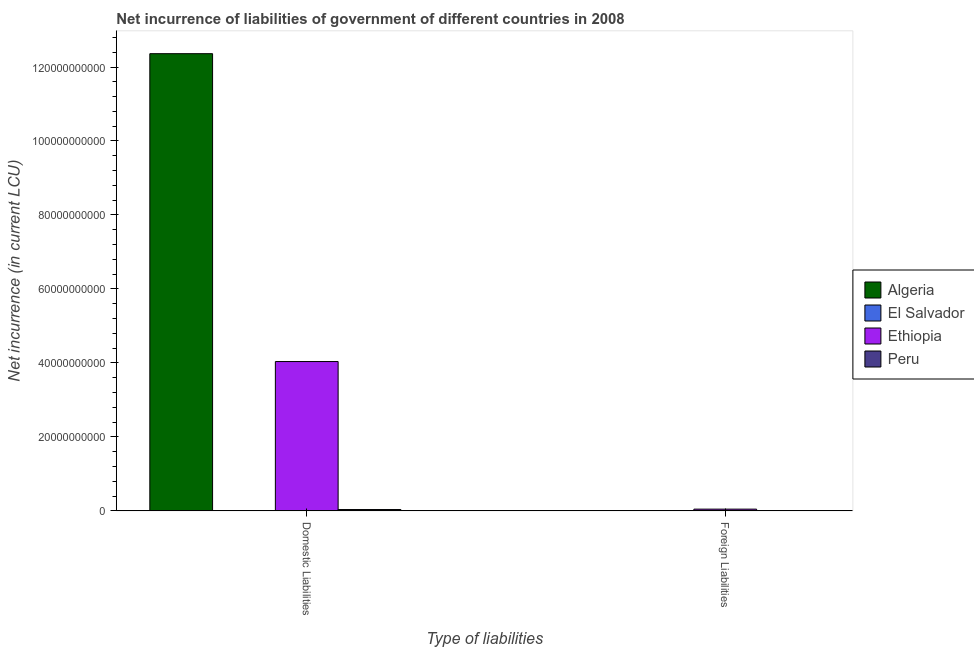How many different coloured bars are there?
Offer a terse response. 3. How many bars are there on the 1st tick from the left?
Ensure brevity in your answer.  3. How many bars are there on the 1st tick from the right?
Give a very brief answer. 1. What is the label of the 2nd group of bars from the left?
Give a very brief answer. Foreign Liabilities. What is the net incurrence of foreign liabilities in El Salvador?
Provide a short and direct response. 0. Across all countries, what is the maximum net incurrence of domestic liabilities?
Offer a terse response. 1.24e+11. In which country was the net incurrence of domestic liabilities maximum?
Your answer should be very brief. Algeria. What is the total net incurrence of foreign liabilities in the graph?
Provide a succinct answer. 4.74e+08. What is the difference between the net incurrence of domestic liabilities in Algeria and that in Ethiopia?
Your response must be concise. 8.32e+1. What is the difference between the net incurrence of domestic liabilities in El Salvador and the net incurrence of foreign liabilities in Ethiopia?
Ensure brevity in your answer.  -4.74e+08. What is the average net incurrence of domestic liabilities per country?
Your answer should be very brief. 4.11e+1. What is the difference between the net incurrence of domestic liabilities and net incurrence of foreign liabilities in Ethiopia?
Your response must be concise. 3.99e+1. What is the ratio of the net incurrence of domestic liabilities in Algeria to that in Ethiopia?
Give a very brief answer. 3.06. Is the net incurrence of domestic liabilities in Peru less than that in Algeria?
Give a very brief answer. Yes. In how many countries, is the net incurrence of foreign liabilities greater than the average net incurrence of foreign liabilities taken over all countries?
Provide a short and direct response. 1. How many bars are there?
Provide a succinct answer. 4. How many countries are there in the graph?
Your answer should be compact. 4. Are the values on the major ticks of Y-axis written in scientific E-notation?
Provide a succinct answer. No. Does the graph contain any zero values?
Ensure brevity in your answer.  Yes. Does the graph contain grids?
Your answer should be compact. No. How are the legend labels stacked?
Provide a succinct answer. Vertical. What is the title of the graph?
Your response must be concise. Net incurrence of liabilities of government of different countries in 2008. Does "Bermuda" appear as one of the legend labels in the graph?
Keep it short and to the point. No. What is the label or title of the X-axis?
Offer a terse response. Type of liabilities. What is the label or title of the Y-axis?
Give a very brief answer. Net incurrence (in current LCU). What is the Net incurrence (in current LCU) of Algeria in Domestic Liabilities?
Ensure brevity in your answer.  1.24e+11. What is the Net incurrence (in current LCU) in El Salvador in Domestic Liabilities?
Give a very brief answer. 0. What is the Net incurrence (in current LCU) of Ethiopia in Domestic Liabilities?
Ensure brevity in your answer.  4.04e+1. What is the Net incurrence (in current LCU) in Peru in Domestic Liabilities?
Offer a very short reply. 3.64e+08. What is the Net incurrence (in current LCU) of Algeria in Foreign Liabilities?
Offer a terse response. 0. What is the Net incurrence (in current LCU) of Ethiopia in Foreign Liabilities?
Offer a very short reply. 4.74e+08. What is the Net incurrence (in current LCU) in Peru in Foreign Liabilities?
Provide a short and direct response. 0. Across all Type of liabilities, what is the maximum Net incurrence (in current LCU) in Algeria?
Offer a very short reply. 1.24e+11. Across all Type of liabilities, what is the maximum Net incurrence (in current LCU) in Ethiopia?
Provide a succinct answer. 4.04e+1. Across all Type of liabilities, what is the maximum Net incurrence (in current LCU) in Peru?
Offer a very short reply. 3.64e+08. Across all Type of liabilities, what is the minimum Net incurrence (in current LCU) of Ethiopia?
Offer a terse response. 4.74e+08. What is the total Net incurrence (in current LCU) in Algeria in the graph?
Offer a very short reply. 1.24e+11. What is the total Net incurrence (in current LCU) in El Salvador in the graph?
Make the answer very short. 0. What is the total Net incurrence (in current LCU) in Ethiopia in the graph?
Give a very brief answer. 4.09e+1. What is the total Net incurrence (in current LCU) of Peru in the graph?
Make the answer very short. 3.64e+08. What is the difference between the Net incurrence (in current LCU) of Ethiopia in Domestic Liabilities and that in Foreign Liabilities?
Provide a succinct answer. 3.99e+1. What is the difference between the Net incurrence (in current LCU) of Algeria in Domestic Liabilities and the Net incurrence (in current LCU) of Ethiopia in Foreign Liabilities?
Keep it short and to the point. 1.23e+11. What is the average Net incurrence (in current LCU) of Algeria per Type of liabilities?
Keep it short and to the point. 6.18e+1. What is the average Net incurrence (in current LCU) of El Salvador per Type of liabilities?
Keep it short and to the point. 0. What is the average Net incurrence (in current LCU) in Ethiopia per Type of liabilities?
Keep it short and to the point. 2.04e+1. What is the average Net incurrence (in current LCU) in Peru per Type of liabilities?
Your answer should be very brief. 1.82e+08. What is the difference between the Net incurrence (in current LCU) of Algeria and Net incurrence (in current LCU) of Ethiopia in Domestic Liabilities?
Your response must be concise. 8.32e+1. What is the difference between the Net incurrence (in current LCU) of Algeria and Net incurrence (in current LCU) of Peru in Domestic Liabilities?
Ensure brevity in your answer.  1.23e+11. What is the difference between the Net incurrence (in current LCU) of Ethiopia and Net incurrence (in current LCU) of Peru in Domestic Liabilities?
Provide a short and direct response. 4.00e+1. What is the ratio of the Net incurrence (in current LCU) of Ethiopia in Domestic Liabilities to that in Foreign Liabilities?
Give a very brief answer. 85.11. What is the difference between the highest and the second highest Net incurrence (in current LCU) in Ethiopia?
Ensure brevity in your answer.  3.99e+1. What is the difference between the highest and the lowest Net incurrence (in current LCU) in Algeria?
Make the answer very short. 1.24e+11. What is the difference between the highest and the lowest Net incurrence (in current LCU) in Ethiopia?
Your answer should be compact. 3.99e+1. What is the difference between the highest and the lowest Net incurrence (in current LCU) in Peru?
Offer a terse response. 3.64e+08. 